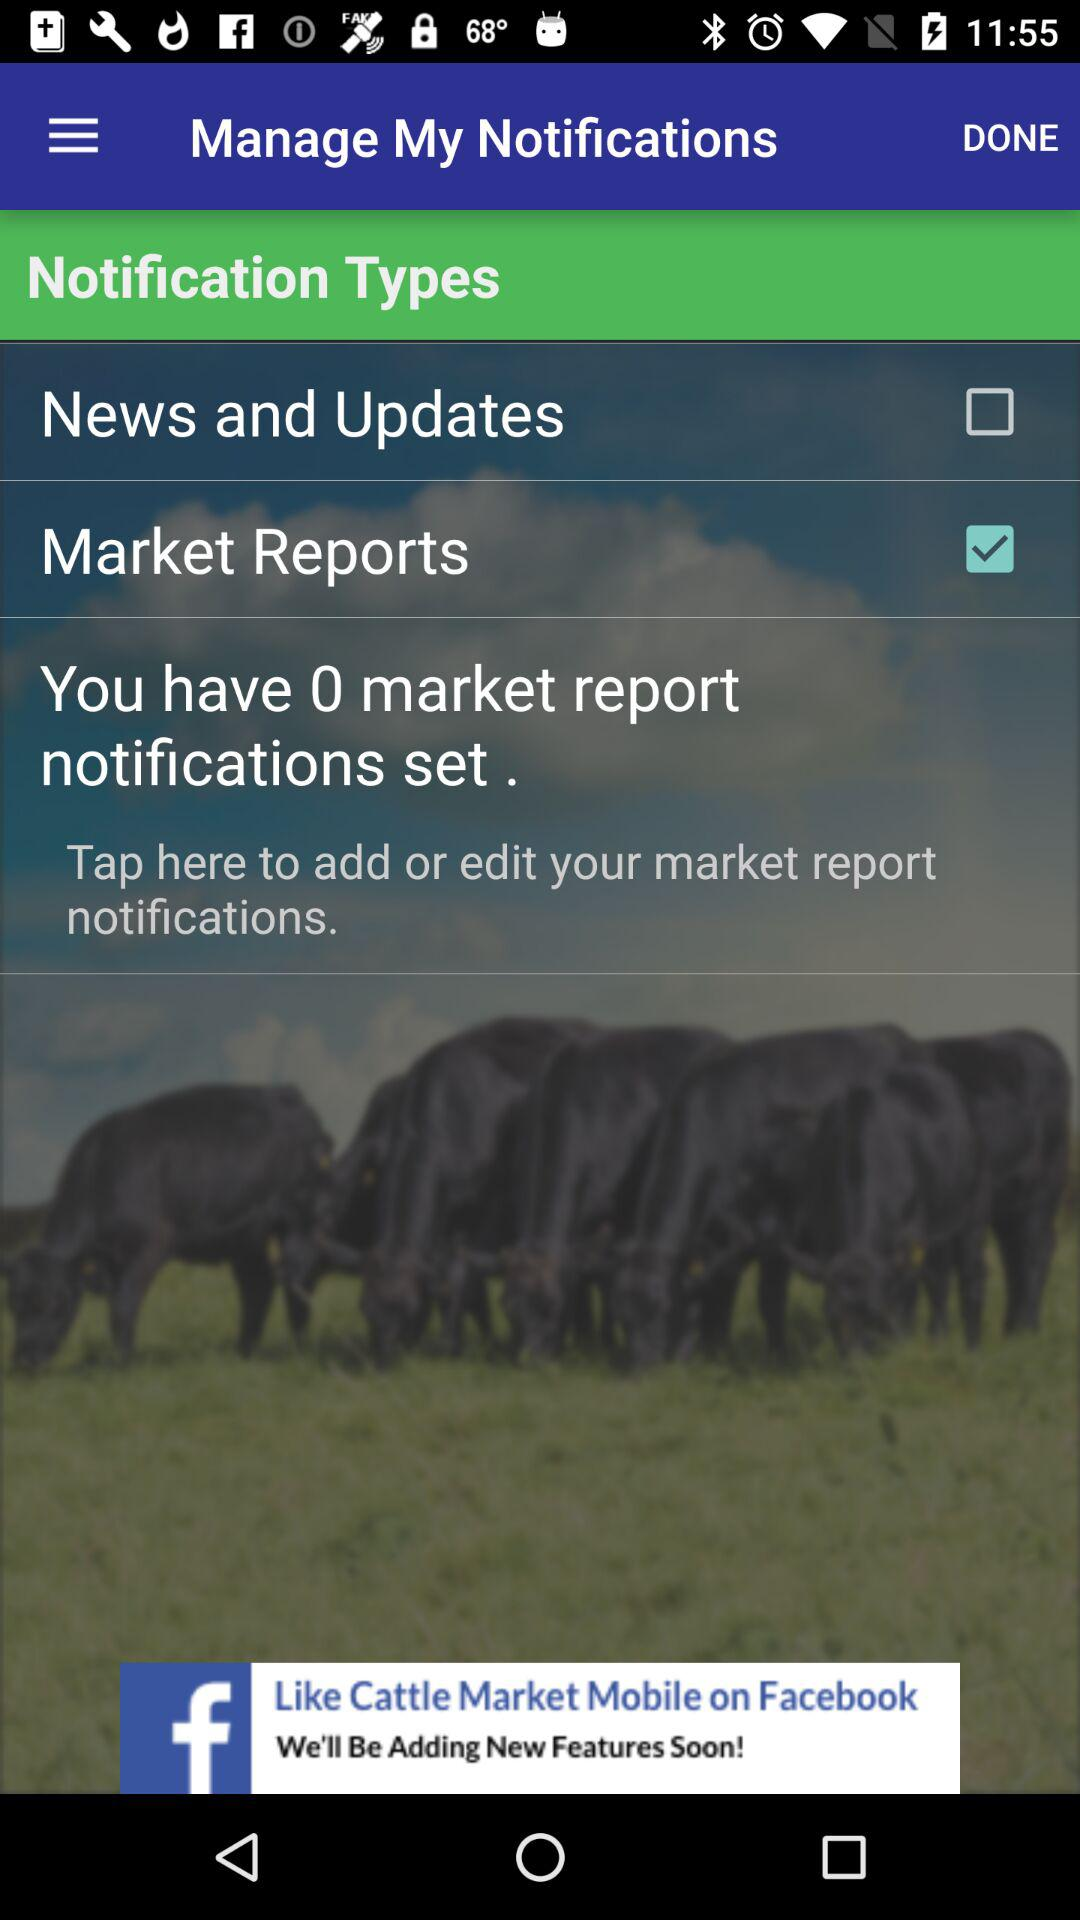How many market report notifications set are there? There are 0 market report notifications set. 